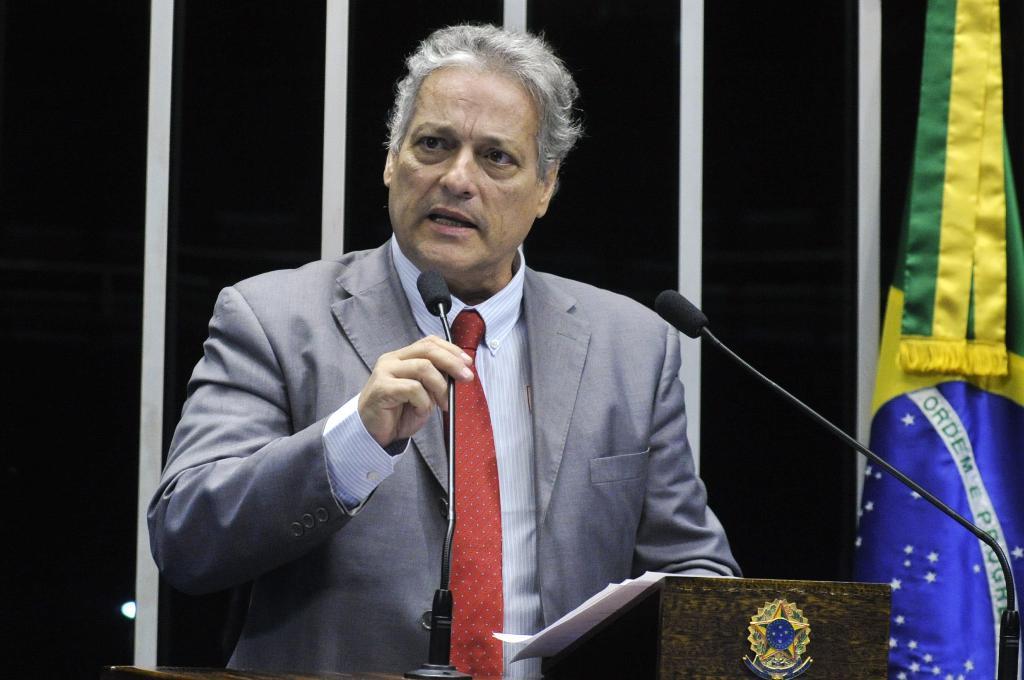Can you describe this image briefly? In the image there is a man in grey suit,shirt and red tie talking on mic in front of dias and behind there is flag in front of the wall. 